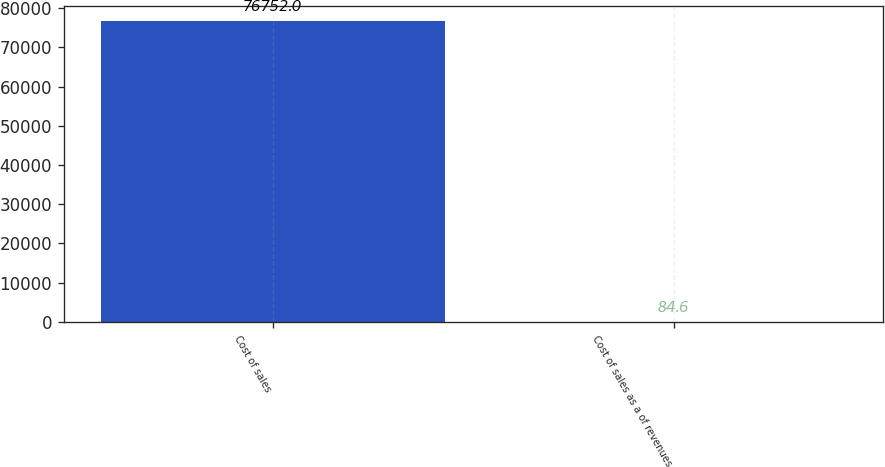Convert chart. <chart><loc_0><loc_0><loc_500><loc_500><bar_chart><fcel>Cost of sales<fcel>Cost of sales as a of revenues<nl><fcel>76752<fcel>84.6<nl></chart> 